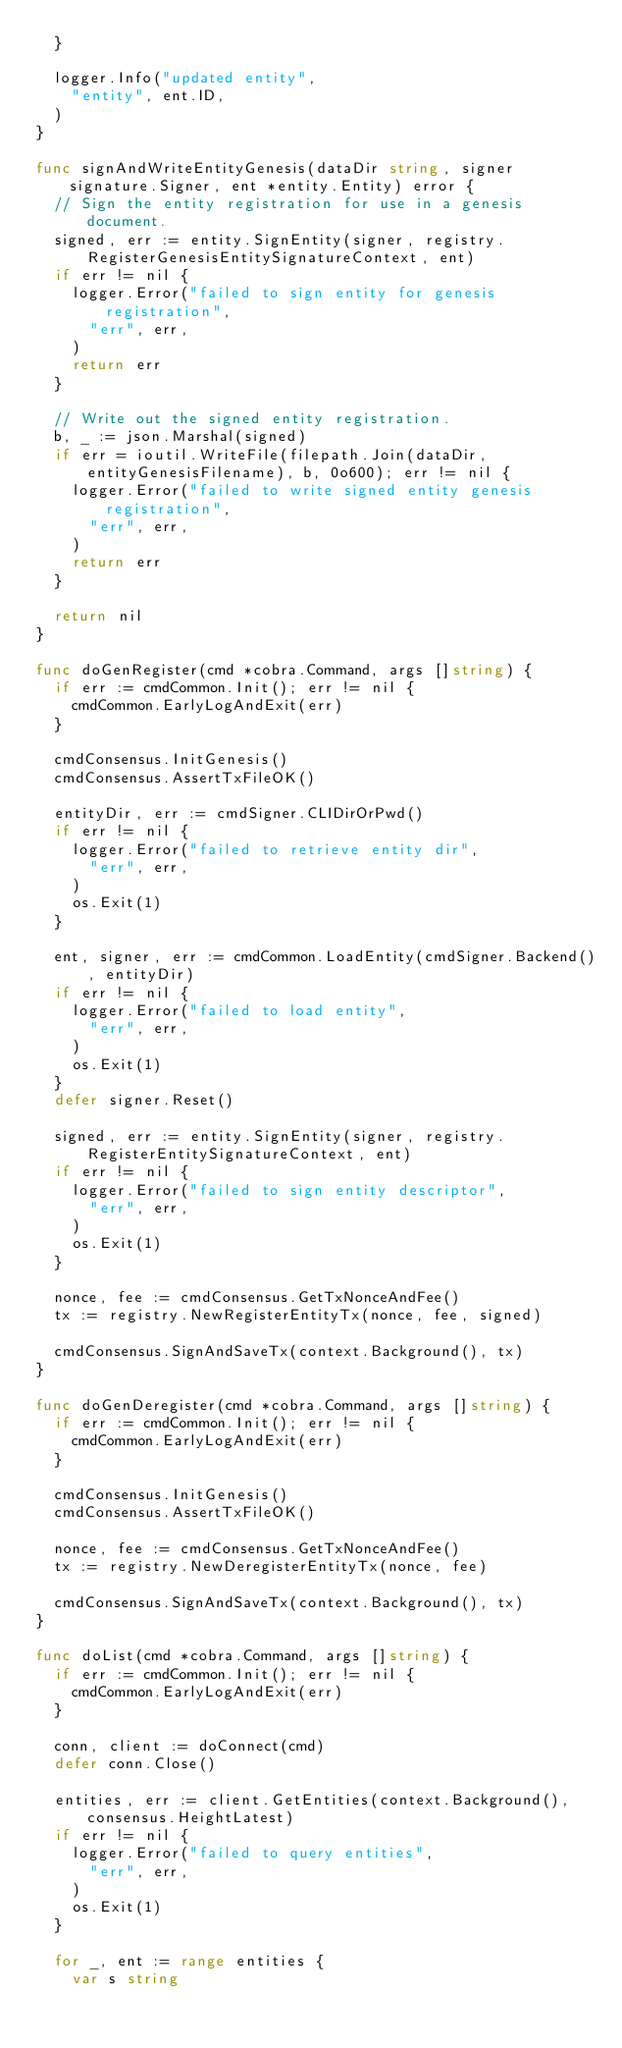Convert code to text. <code><loc_0><loc_0><loc_500><loc_500><_Go_>	}

	logger.Info("updated entity",
		"entity", ent.ID,
	)
}

func signAndWriteEntityGenesis(dataDir string, signer signature.Signer, ent *entity.Entity) error {
	// Sign the entity registration for use in a genesis document.
	signed, err := entity.SignEntity(signer, registry.RegisterGenesisEntitySignatureContext, ent)
	if err != nil {
		logger.Error("failed to sign entity for genesis registration",
			"err", err,
		)
		return err
	}

	// Write out the signed entity registration.
	b, _ := json.Marshal(signed)
	if err = ioutil.WriteFile(filepath.Join(dataDir, entityGenesisFilename), b, 0o600); err != nil {
		logger.Error("failed to write signed entity genesis registration",
			"err", err,
		)
		return err
	}

	return nil
}

func doGenRegister(cmd *cobra.Command, args []string) {
	if err := cmdCommon.Init(); err != nil {
		cmdCommon.EarlyLogAndExit(err)
	}

	cmdConsensus.InitGenesis()
	cmdConsensus.AssertTxFileOK()

	entityDir, err := cmdSigner.CLIDirOrPwd()
	if err != nil {
		logger.Error("failed to retrieve entity dir",
			"err", err,
		)
		os.Exit(1)
	}

	ent, signer, err := cmdCommon.LoadEntity(cmdSigner.Backend(), entityDir)
	if err != nil {
		logger.Error("failed to load entity",
			"err", err,
		)
		os.Exit(1)
	}
	defer signer.Reset()

	signed, err := entity.SignEntity(signer, registry.RegisterEntitySignatureContext, ent)
	if err != nil {
		logger.Error("failed to sign entity descriptor",
			"err", err,
		)
		os.Exit(1)
	}

	nonce, fee := cmdConsensus.GetTxNonceAndFee()
	tx := registry.NewRegisterEntityTx(nonce, fee, signed)

	cmdConsensus.SignAndSaveTx(context.Background(), tx)
}

func doGenDeregister(cmd *cobra.Command, args []string) {
	if err := cmdCommon.Init(); err != nil {
		cmdCommon.EarlyLogAndExit(err)
	}

	cmdConsensus.InitGenesis()
	cmdConsensus.AssertTxFileOK()

	nonce, fee := cmdConsensus.GetTxNonceAndFee()
	tx := registry.NewDeregisterEntityTx(nonce, fee)

	cmdConsensus.SignAndSaveTx(context.Background(), tx)
}

func doList(cmd *cobra.Command, args []string) {
	if err := cmdCommon.Init(); err != nil {
		cmdCommon.EarlyLogAndExit(err)
	}

	conn, client := doConnect(cmd)
	defer conn.Close()

	entities, err := client.GetEntities(context.Background(), consensus.HeightLatest)
	if err != nil {
		logger.Error("failed to query entities",
			"err", err,
		)
		os.Exit(1)
	}

	for _, ent := range entities {
		var s string</code> 